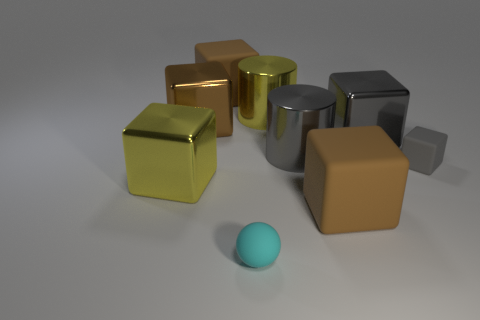Subtract all gray cubes. How many were subtracted if there are1gray cubes left? 1 Subtract all brown blocks. How many blocks are left? 3 Subtract all yellow cubes. How many cubes are left? 5 Subtract 2 gray cubes. How many objects are left? 7 Subtract all cylinders. How many objects are left? 7 Subtract 1 balls. How many balls are left? 0 Subtract all green blocks. Subtract all purple balls. How many blocks are left? 6 Subtract all yellow cylinders. How many brown spheres are left? 0 Subtract all small cyan rubber objects. Subtract all big gray things. How many objects are left? 6 Add 2 brown rubber things. How many brown rubber things are left? 4 